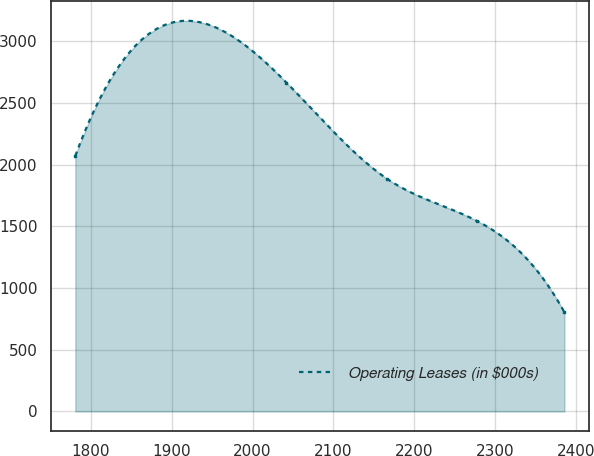Convert chart to OTSL. <chart><loc_0><loc_0><loc_500><loc_500><line_chart><ecel><fcel>Operating Leases (in $000s)<nl><fcel>1780.77<fcel>2072.2<nl><fcel>2041.87<fcel>2666.33<nl><fcel>2166.39<fcel>1885.92<nl><fcel>2277.3<fcel>1545.44<nl><fcel>2385.92<fcel>803.48<nl></chart> 